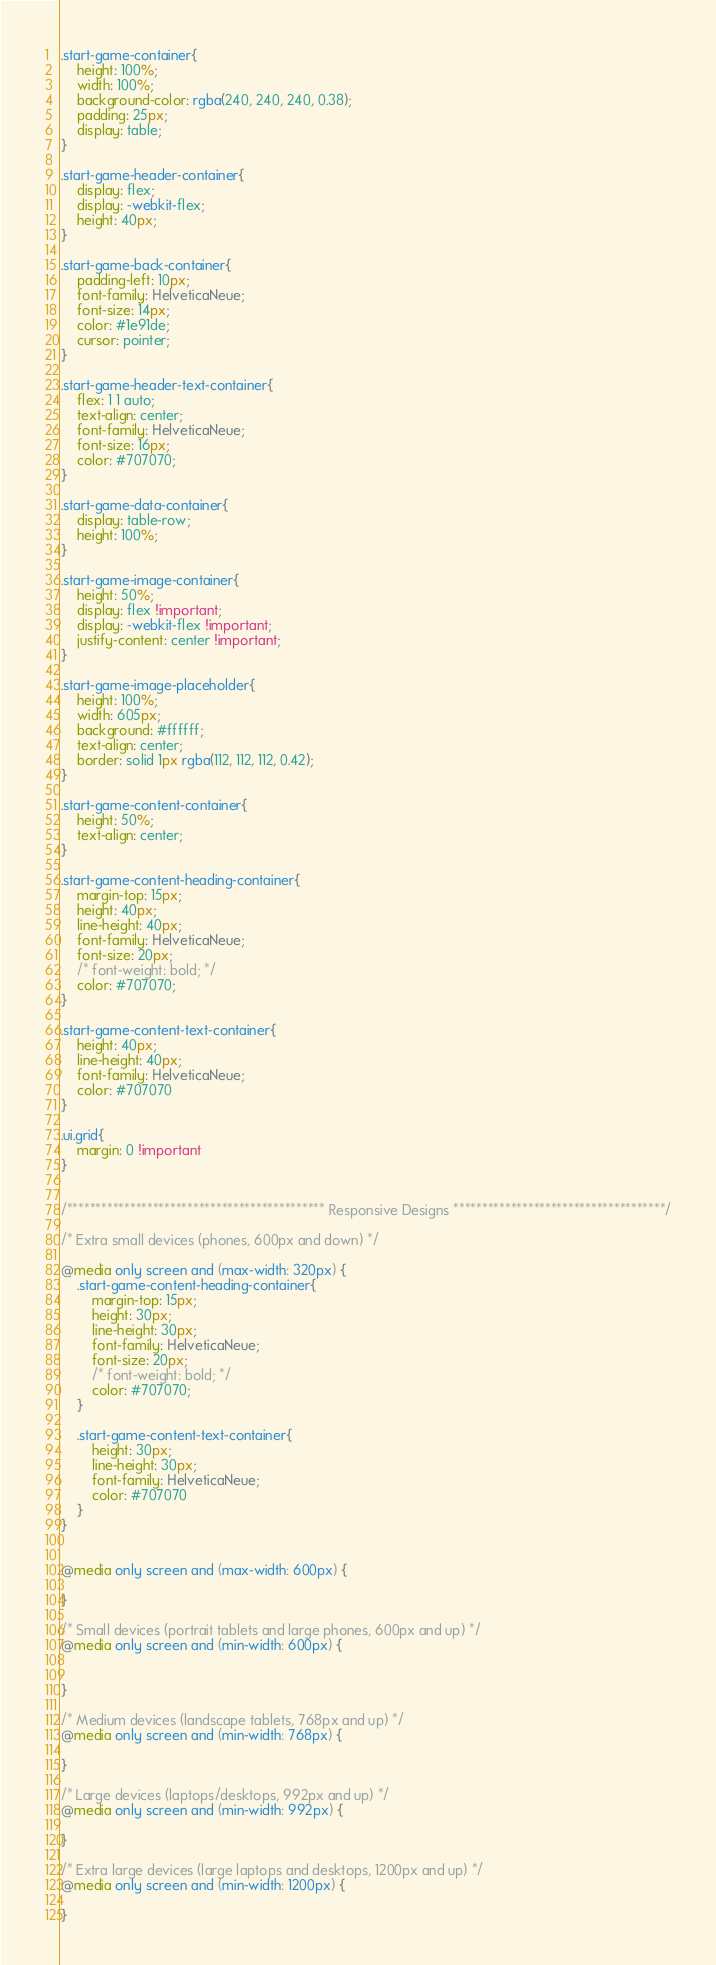<code> <loc_0><loc_0><loc_500><loc_500><_CSS_>.start-game-container{
    height: 100%;
    width: 100%;
    background-color: rgba(240, 240, 240, 0.38);
    padding: 25px;
    display: table;
}

.start-game-header-container{
    display: flex;
    display: -webkit-flex;
    height: 40px;
}

.start-game-back-container{
    padding-left: 10px;
    font-family: HelveticaNeue;
    font-size: 14px;
    color: #1e91de;
    cursor: pointer;
}

.start-game-header-text-container{
    flex: 1 1 auto;
    text-align: center;
    font-family: HelveticaNeue;
    font-size: 16px;
    color: #707070;
}

.start-game-data-container{
    display: table-row;
    height: 100%;
}

.start-game-image-container{
    height: 50%;    
    display: flex !important;
    display: -webkit-flex !important;
    justify-content: center !important;
}

.start-game-image-placeholder{
    height: 100%;
    width: 605px;
    background: #ffffff;
    text-align: center;
    border: solid 1px rgba(112, 112, 112, 0.42);
}

.start-game-content-container{
    height: 50%;
    text-align: center;
}

.start-game-content-heading-container{
    margin-top: 15px;
    height: 40px;
    line-height: 40px;
    font-family: HelveticaNeue;
    font-size: 20px;
    /* font-weight: bold; */
    color: #707070;
}

.start-game-content-text-container{
    height: 40px;
    line-height: 40px;
    font-family: HelveticaNeue;
    color: #707070
}

.ui.grid{
    margin: 0 !important
}


/********************************************* Responsive Designs *************************************/

/* Extra small devices (phones, 600px and down) */

@media only screen and (max-width: 320px) {
    .start-game-content-heading-container{
        margin-top: 15px;
        height: 30px;
        line-height: 30px;
        font-family: HelveticaNeue;
        font-size: 20px;
        /* font-weight: bold; */
        color: #707070;
    }

    .start-game-content-text-container{
        height: 30px;
        line-height: 30px;
        font-family: HelveticaNeue;
        color: #707070
    }
} 


@media only screen and (max-width: 600px) {

} 

/* Small devices (portrait tablets and large phones, 600px and up) */
@media only screen and (min-width: 600px) {
    
    
} 

/* Medium devices (landscape tablets, 768px and up) */
@media only screen and (min-width: 768px) {
   
} 

/* Large devices (laptops/desktops, 992px and up) */
@media only screen and (min-width: 992px) {

} 

/* Extra large devices (large laptops and desktops, 1200px and up) */
@media only screen and (min-width: 1200px) {

}</code> 